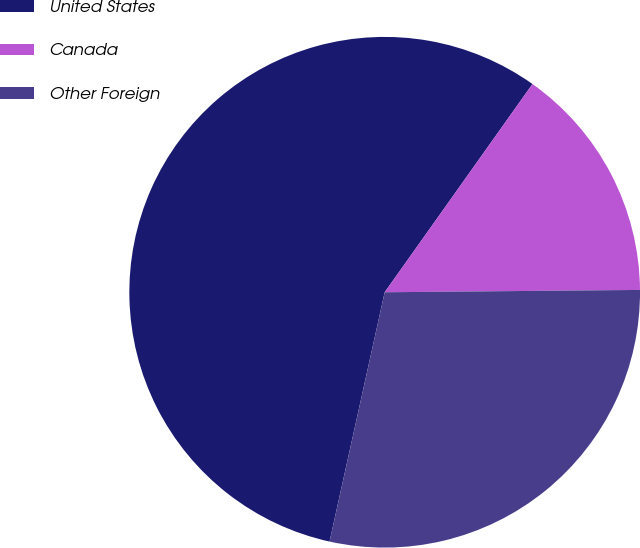Convert chart to OTSL. <chart><loc_0><loc_0><loc_500><loc_500><pie_chart><fcel>United States<fcel>Canada<fcel>Other Foreign<nl><fcel>56.36%<fcel>15.03%<fcel>28.61%<nl></chart> 